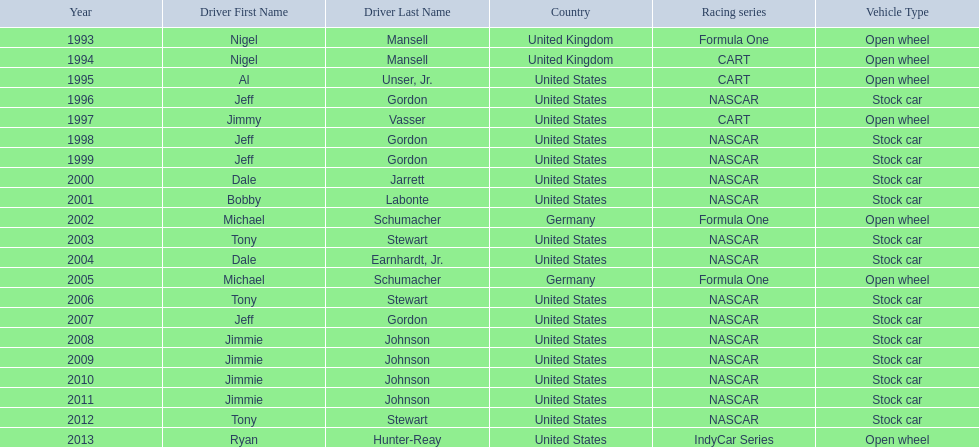Which driver had four consecutive wins? Jimmie Johnson. 